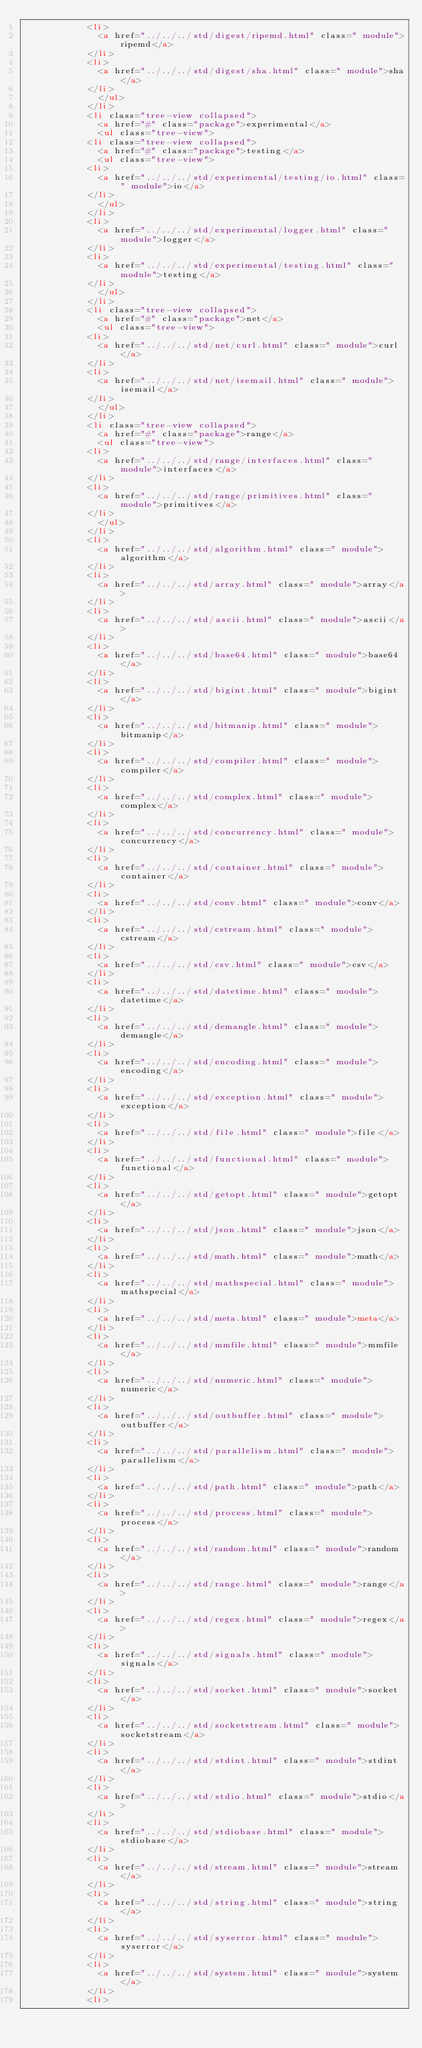<code> <loc_0><loc_0><loc_500><loc_500><_HTML_>						<li>
							<a href="../../../std/digest/ripemd.html" class=" module">ripemd</a>
						</li>
						<li>
							<a href="../../../std/digest/sha.html" class=" module">sha</a>
						</li>
							</ul>
						</li>
						<li class="tree-view collapsed">
							<a href="#" class="package">experimental</a>
							<ul class="tree-view">
						<li class="tree-view collapsed">
							<a href="#" class="package">testing</a>
							<ul class="tree-view">
						<li>
							<a href="../../../std/experimental/testing/io.html" class=" module">io</a>
						</li>
							</ul>
						</li>
						<li>
							<a href="../../../std/experimental/logger.html" class=" module">logger</a>
						</li>
						<li>
							<a href="../../../std/experimental/testing.html" class=" module">testing</a>
						</li>
							</ul>
						</li>
						<li class="tree-view collapsed">
							<a href="#" class="package">net</a>
							<ul class="tree-view">
						<li>
							<a href="../../../std/net/curl.html" class=" module">curl</a>
						</li>
						<li>
							<a href="../../../std/net/isemail.html" class=" module">isemail</a>
						</li>
							</ul>
						</li>
						<li class="tree-view collapsed">
							<a href="#" class="package">range</a>
							<ul class="tree-view">
						<li>
							<a href="../../../std/range/interfaces.html" class=" module">interfaces</a>
						</li>
						<li>
							<a href="../../../std/range/primitives.html" class=" module">primitives</a>
						</li>
							</ul>
						</li>
						<li>
							<a href="../../../std/algorithm.html" class=" module">algorithm</a>
						</li>
						<li>
							<a href="../../../std/array.html" class=" module">array</a>
						</li>
						<li>
							<a href="../../../std/ascii.html" class=" module">ascii</a>
						</li>
						<li>
							<a href="../../../std/base64.html" class=" module">base64</a>
						</li>
						<li>
							<a href="../../../std/bigint.html" class=" module">bigint</a>
						</li>
						<li>
							<a href="../../../std/bitmanip.html" class=" module">bitmanip</a>
						</li>
						<li>
							<a href="../../../std/compiler.html" class=" module">compiler</a>
						</li>
						<li>
							<a href="../../../std/complex.html" class=" module">complex</a>
						</li>
						<li>
							<a href="../../../std/concurrency.html" class=" module">concurrency</a>
						</li>
						<li>
							<a href="../../../std/container.html" class=" module">container</a>
						</li>
						<li>
							<a href="../../../std/conv.html" class=" module">conv</a>
						</li>
						<li>
							<a href="../../../std/cstream.html" class=" module">cstream</a>
						</li>
						<li>
							<a href="../../../std/csv.html" class=" module">csv</a>
						</li>
						<li>
							<a href="../../../std/datetime.html" class=" module">datetime</a>
						</li>
						<li>
							<a href="../../../std/demangle.html" class=" module">demangle</a>
						</li>
						<li>
							<a href="../../../std/encoding.html" class=" module">encoding</a>
						</li>
						<li>
							<a href="../../../std/exception.html" class=" module">exception</a>
						</li>
						<li>
							<a href="../../../std/file.html" class=" module">file</a>
						</li>
						<li>
							<a href="../../../std/functional.html" class=" module">functional</a>
						</li>
						<li>
							<a href="../../../std/getopt.html" class=" module">getopt</a>
						</li>
						<li>
							<a href="../../../std/json.html" class=" module">json</a>
						</li>
						<li>
							<a href="../../../std/math.html" class=" module">math</a>
						</li>
						<li>
							<a href="../../../std/mathspecial.html" class=" module">mathspecial</a>
						</li>
						<li>
							<a href="../../../std/meta.html" class=" module">meta</a>
						</li>
						<li>
							<a href="../../../std/mmfile.html" class=" module">mmfile</a>
						</li>
						<li>
							<a href="../../../std/numeric.html" class=" module">numeric</a>
						</li>
						<li>
							<a href="../../../std/outbuffer.html" class=" module">outbuffer</a>
						</li>
						<li>
							<a href="../../../std/parallelism.html" class=" module">parallelism</a>
						</li>
						<li>
							<a href="../../../std/path.html" class=" module">path</a>
						</li>
						<li>
							<a href="../../../std/process.html" class=" module">process</a>
						</li>
						<li>
							<a href="../../../std/random.html" class=" module">random</a>
						</li>
						<li>
							<a href="../../../std/range.html" class=" module">range</a>
						</li>
						<li>
							<a href="../../../std/regex.html" class=" module">regex</a>
						</li>
						<li>
							<a href="../../../std/signals.html" class=" module">signals</a>
						</li>
						<li>
							<a href="../../../std/socket.html" class=" module">socket</a>
						</li>
						<li>
							<a href="../../../std/socketstream.html" class=" module">socketstream</a>
						</li>
						<li>
							<a href="../../../std/stdint.html" class=" module">stdint</a>
						</li>
						<li>
							<a href="../../../std/stdio.html" class=" module">stdio</a>
						</li>
						<li>
							<a href="../../../std/stdiobase.html" class=" module">stdiobase</a>
						</li>
						<li>
							<a href="../../../std/stream.html" class=" module">stream</a>
						</li>
						<li>
							<a href="../../../std/string.html" class=" module">string</a>
						</li>
						<li>
							<a href="../../../std/syserror.html" class=" module">syserror</a>
						</li>
						<li>
							<a href="../../../std/system.html" class=" module">system</a>
						</li>
						<li></code> 